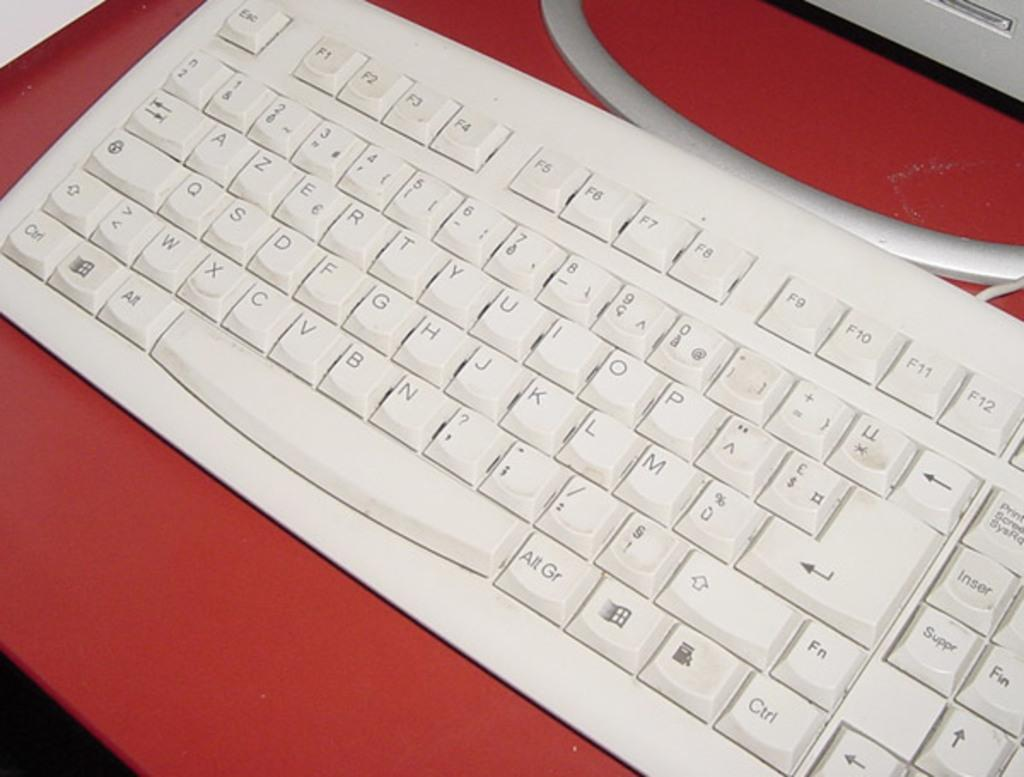<image>
Offer a succinct explanation of the picture presented. A keyboard that has all of the keys including that ones that say Ctrl and Alt is sitting on a red table. 